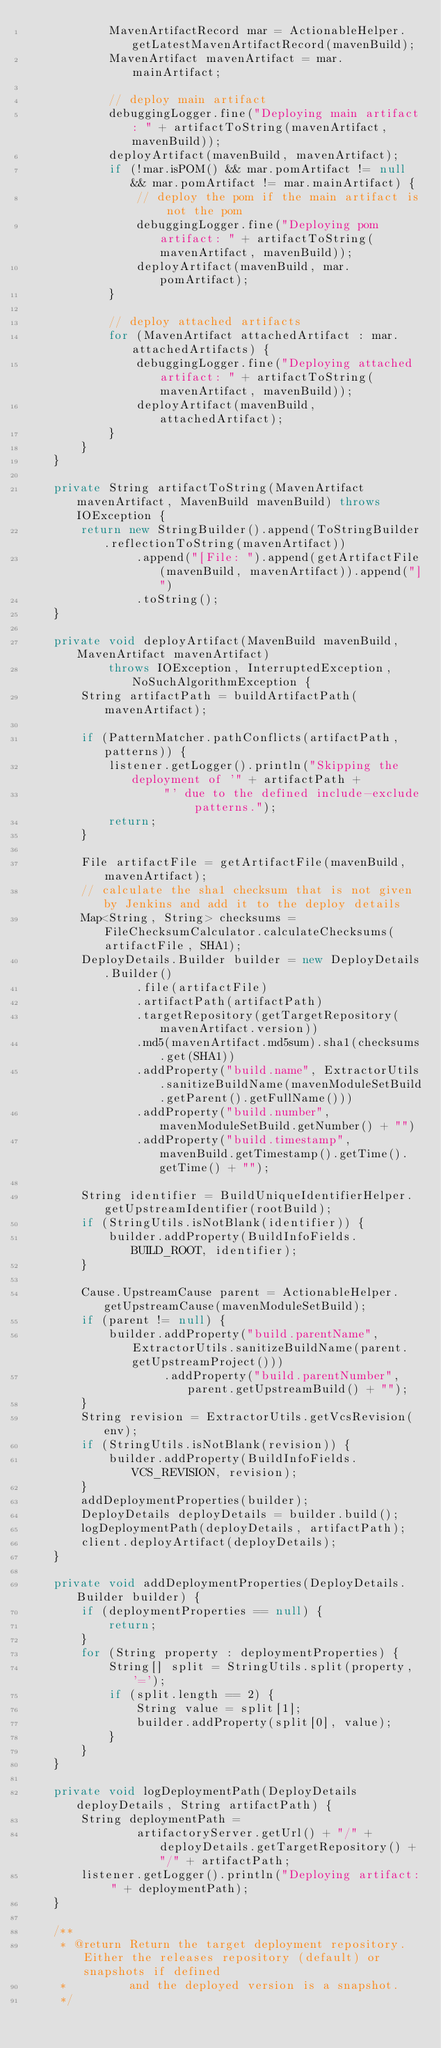Convert code to text. <code><loc_0><loc_0><loc_500><loc_500><_Java_>            MavenArtifactRecord mar = ActionableHelper.getLatestMavenArtifactRecord(mavenBuild);
            MavenArtifact mavenArtifact = mar.mainArtifact;

            // deploy main artifact
            debuggingLogger.fine("Deploying main artifact: " + artifactToString(mavenArtifact, mavenBuild));
            deployArtifact(mavenBuild, mavenArtifact);
            if (!mar.isPOM() && mar.pomArtifact != null && mar.pomArtifact != mar.mainArtifact) {
                // deploy the pom if the main artifact is not the pom
                debuggingLogger.fine("Deploying pom artifact: " + artifactToString(mavenArtifact, mavenBuild));
                deployArtifact(mavenBuild, mar.pomArtifact);
            }

            // deploy attached artifacts
            for (MavenArtifact attachedArtifact : mar.attachedArtifacts) {
                debuggingLogger.fine("Deploying attached artifact: " + artifactToString(mavenArtifact, mavenBuild));
                deployArtifact(mavenBuild, attachedArtifact);
            }
        }
    }

    private String artifactToString(MavenArtifact mavenArtifact, MavenBuild mavenBuild) throws IOException {
        return new StringBuilder().append(ToStringBuilder.reflectionToString(mavenArtifact))
                .append("[File: ").append(getArtifactFile(mavenBuild, mavenArtifact)).append("]")
                .toString();
    }

    private void deployArtifact(MavenBuild mavenBuild, MavenArtifact mavenArtifact)
            throws IOException, InterruptedException, NoSuchAlgorithmException {
        String artifactPath = buildArtifactPath(mavenArtifact);

        if (PatternMatcher.pathConflicts(artifactPath, patterns)) {
            listener.getLogger().println("Skipping the deployment of '" + artifactPath +
                    "' due to the defined include-exclude patterns.");
            return;
        }

        File artifactFile = getArtifactFile(mavenBuild, mavenArtifact);
        // calculate the sha1 checksum that is not given by Jenkins and add it to the deploy details
        Map<String, String> checksums = FileChecksumCalculator.calculateChecksums(artifactFile, SHA1);
        DeployDetails.Builder builder = new DeployDetails.Builder()
                .file(artifactFile)
                .artifactPath(artifactPath)
                .targetRepository(getTargetRepository(mavenArtifact.version))
                .md5(mavenArtifact.md5sum).sha1(checksums.get(SHA1))
                .addProperty("build.name", ExtractorUtils.sanitizeBuildName(mavenModuleSetBuild.getParent().getFullName()))
                .addProperty("build.number", mavenModuleSetBuild.getNumber() + "")
                .addProperty("build.timestamp", mavenBuild.getTimestamp().getTime().getTime() + "");

        String identifier = BuildUniqueIdentifierHelper.getUpstreamIdentifier(rootBuild);
        if (StringUtils.isNotBlank(identifier)) {
            builder.addProperty(BuildInfoFields.BUILD_ROOT, identifier);
        }

        Cause.UpstreamCause parent = ActionableHelper.getUpstreamCause(mavenModuleSetBuild);
        if (parent != null) {
            builder.addProperty("build.parentName", ExtractorUtils.sanitizeBuildName(parent.getUpstreamProject()))
                    .addProperty("build.parentNumber", parent.getUpstreamBuild() + "");
        }
        String revision = ExtractorUtils.getVcsRevision(env);
        if (StringUtils.isNotBlank(revision)) {
            builder.addProperty(BuildInfoFields.VCS_REVISION, revision);
        }
        addDeploymentProperties(builder);
        DeployDetails deployDetails = builder.build();
        logDeploymentPath(deployDetails, artifactPath);
        client.deployArtifact(deployDetails);
    }

    private void addDeploymentProperties(DeployDetails.Builder builder) {
        if (deploymentProperties == null) {
            return;
        }
        for (String property : deploymentProperties) {
            String[] split = StringUtils.split(property, '=');
            if (split.length == 2) {
                String value = split[1];
                builder.addProperty(split[0], value);
            }
        }
    }

    private void logDeploymentPath(DeployDetails deployDetails, String artifactPath) {
        String deploymentPath =
                artifactoryServer.getUrl() + "/" + deployDetails.getTargetRepository() + "/" + artifactPath;
        listener.getLogger().println("Deploying artifact: " + deploymentPath);
    }

    /**
     * @return Return the target deployment repository. Either the releases repository (default) or snapshots if defined
     *         and the deployed version is a snapshot.
     */</code> 